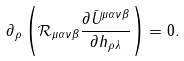Convert formula to latex. <formula><loc_0><loc_0><loc_500><loc_500>\partial _ { \rho } \left ( \mathcal { R } _ { \mu \alpha \nu \beta } \frac { \partial \bar { U } ^ { \mu \alpha \nu \beta } } { \partial h _ { \rho \lambda } } \right ) = 0 .</formula> 